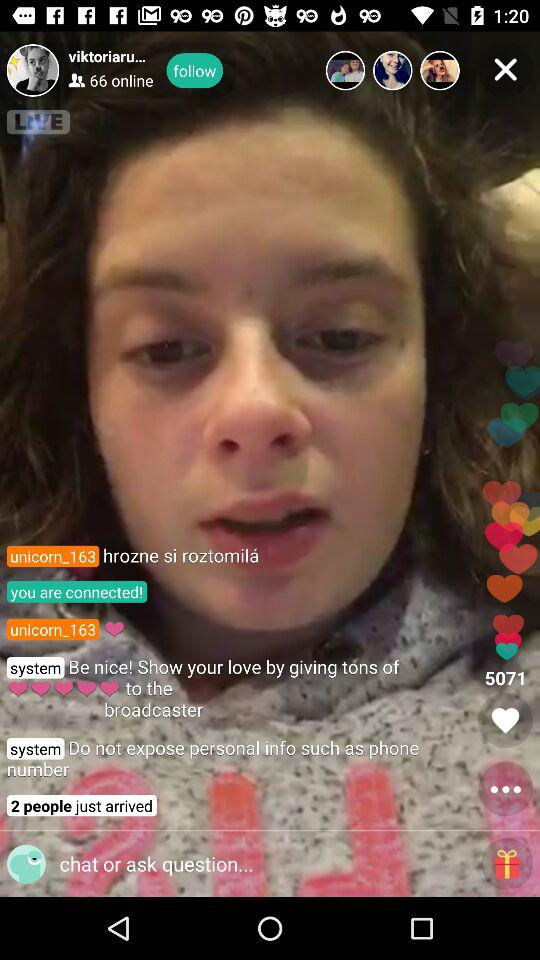How many people just arrived?
Answer the question using a single word or phrase. 2 